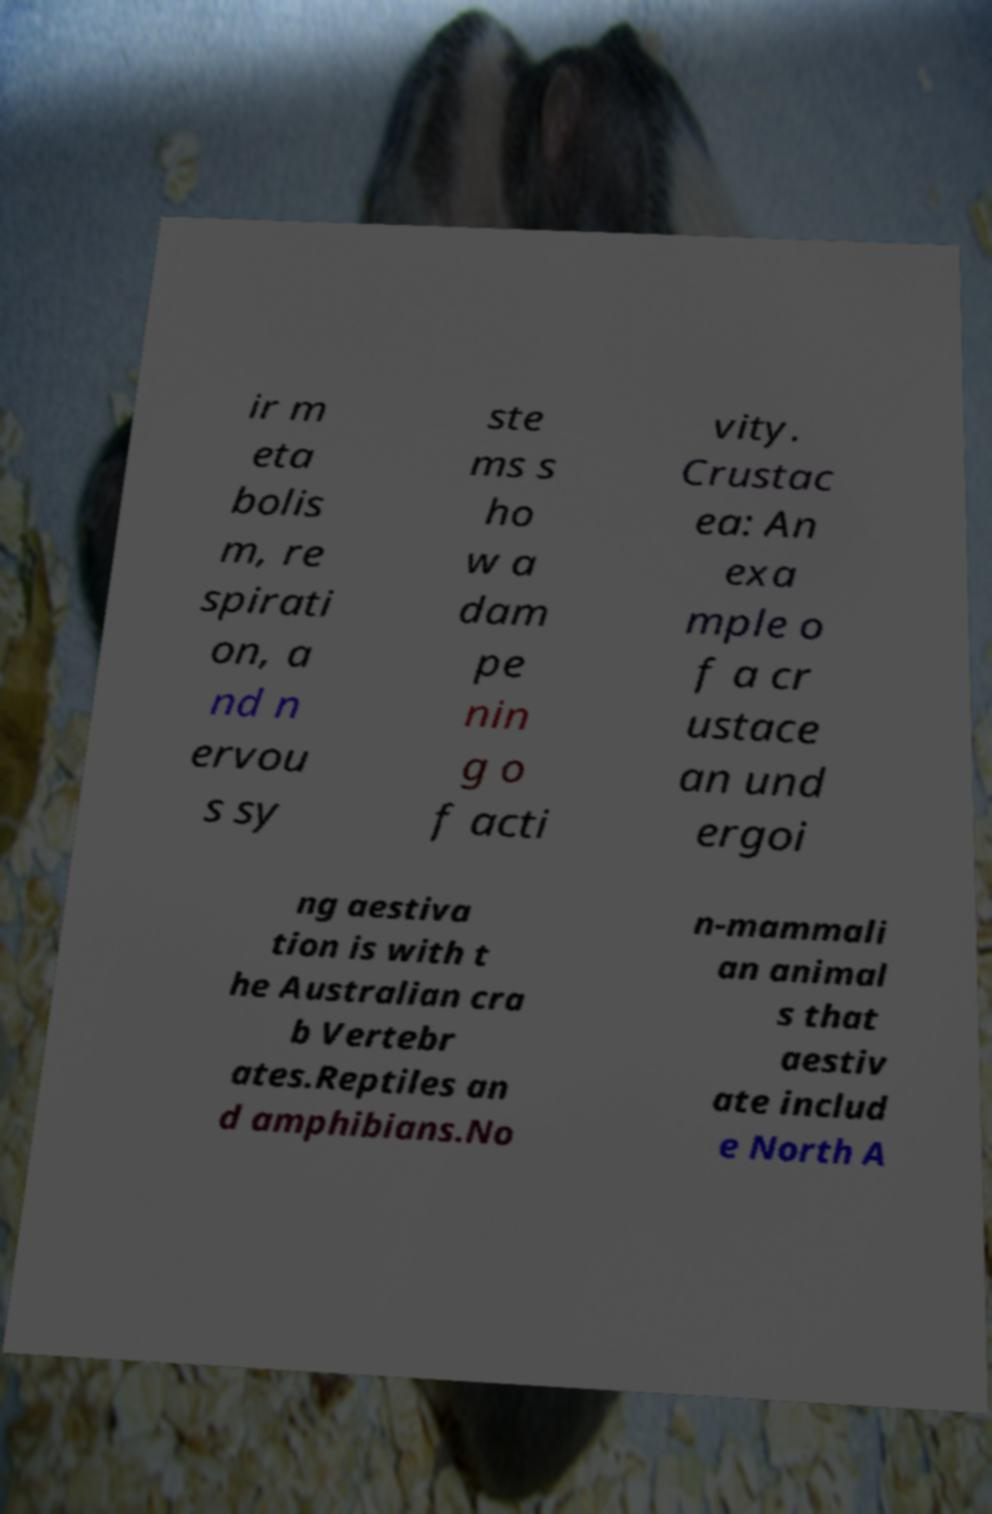For documentation purposes, I need the text within this image transcribed. Could you provide that? ir m eta bolis m, re spirati on, a nd n ervou s sy ste ms s ho w a dam pe nin g o f acti vity. Crustac ea: An exa mple o f a cr ustace an und ergoi ng aestiva tion is with t he Australian cra b Vertebr ates.Reptiles an d amphibians.No n-mammali an animal s that aestiv ate includ e North A 